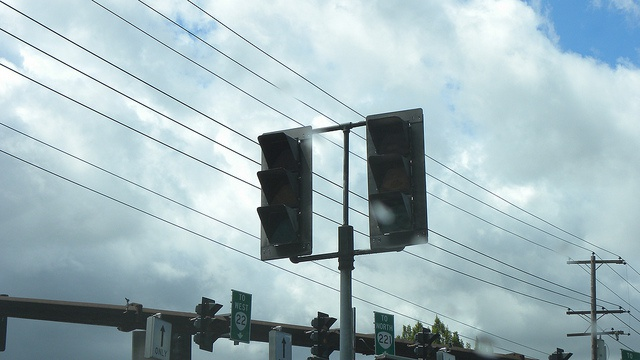Describe the objects in this image and their specific colors. I can see traffic light in darkgray, black, and purple tones, traffic light in darkgray, black, gray, white, and purple tones, traffic light in darkgray, black, and purple tones, traffic light in darkgray, black, and gray tones, and traffic light in darkgray, black, gray, darkgreen, and darkblue tones in this image. 